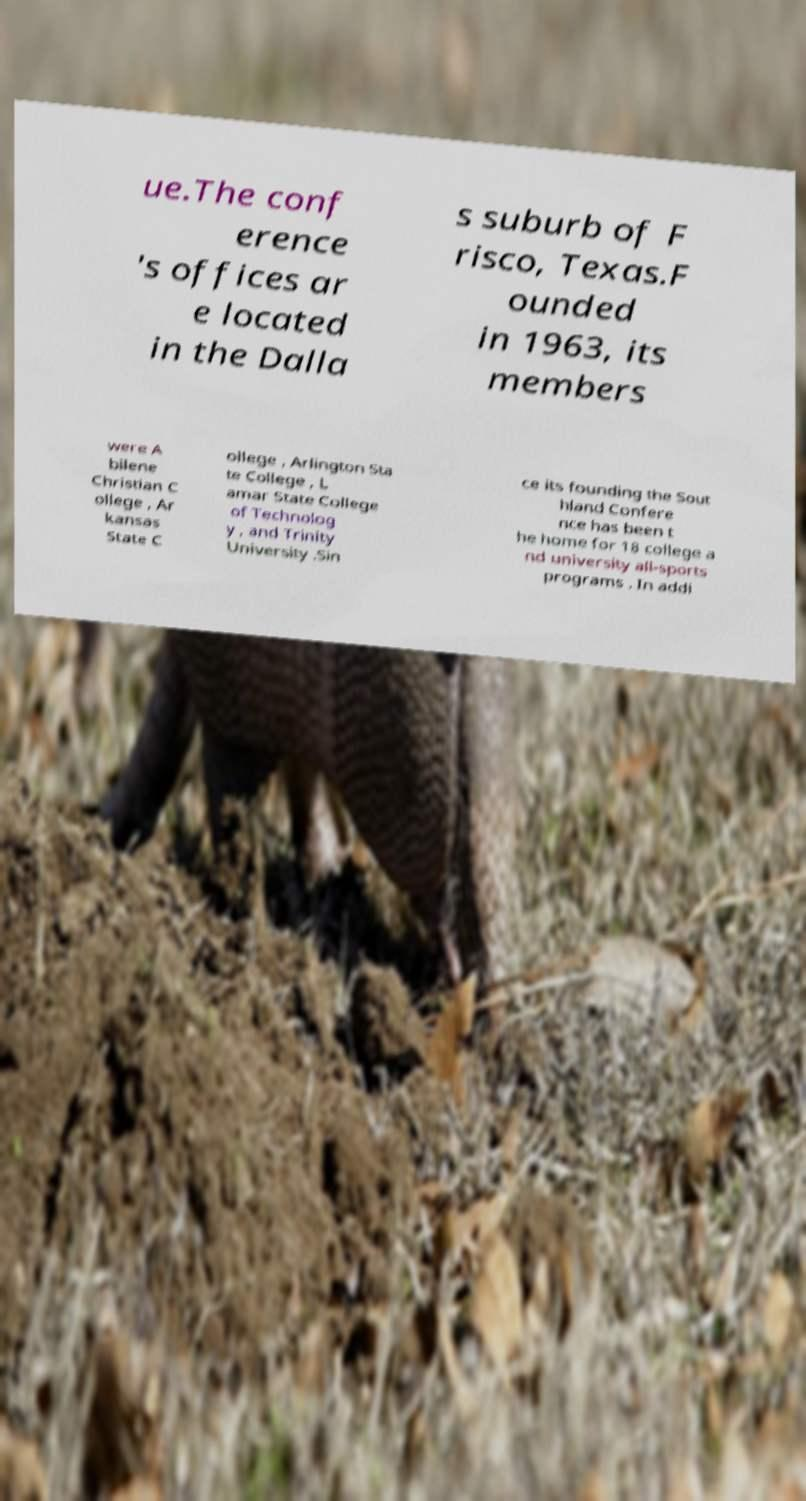Can you accurately transcribe the text from the provided image for me? ue.The conf erence 's offices ar e located in the Dalla s suburb of F risco, Texas.F ounded in 1963, its members were A bilene Christian C ollege , Ar kansas State C ollege , Arlington Sta te College , L amar State College of Technolog y , and Trinity University .Sin ce its founding the Sout hland Confere nce has been t he home for 18 college a nd university all-sports programs . In addi 